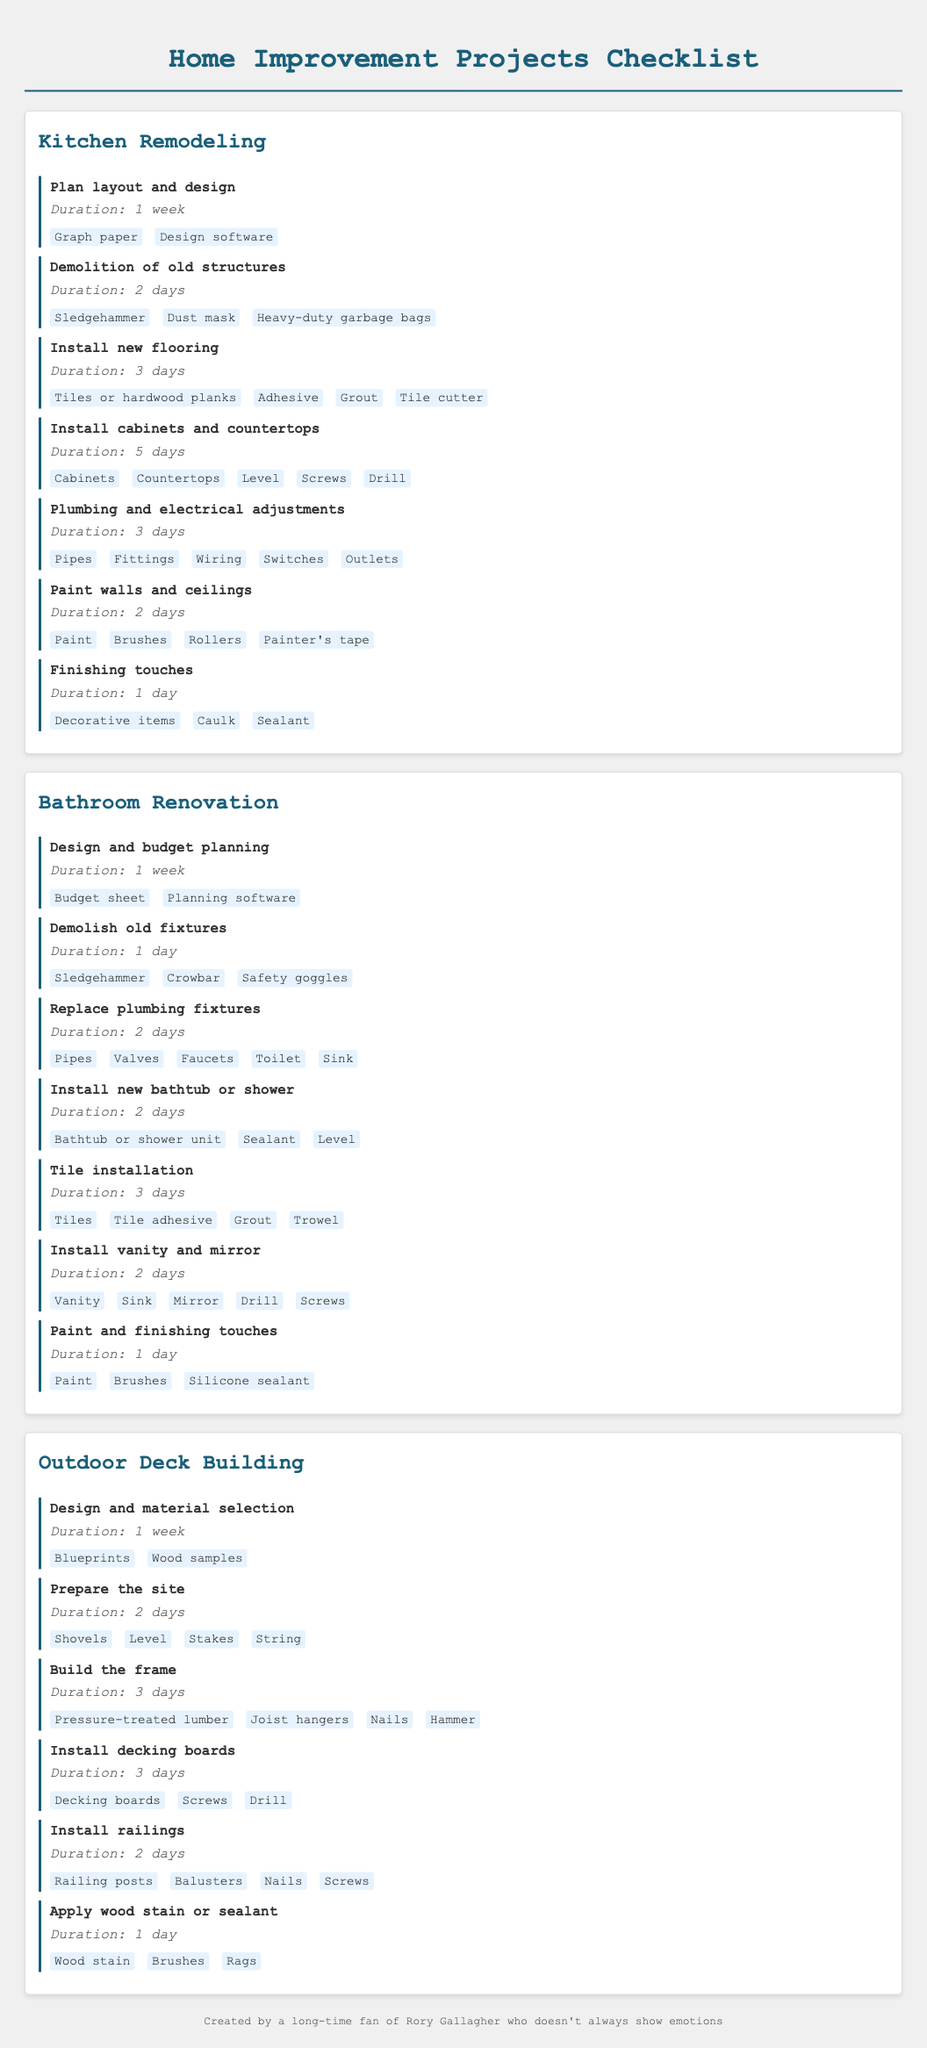What is the duration for installing cabinets and countertops? The duration for installing cabinets and countertops is specified in the kitchen remodeling section of the document.
Answer: 5 days What materials are needed for demolishing old structures in the kitchen? The materials listed for demolishing old structures include items that specifically help with this task in the kitchen remodeling section.
Answer: Sledgehammer, Dust mask, Heavy-duty garbage bags How many days does the tile installation in the bathroom take? The document explicitly states the duration for tile installation under the bathroom renovation section.
Answer: 3 days What task requires the use of wood stain in outdoor deck building? The specific task that involves wood stain is outlined in the outdoor deck building section of the document.
Answer: Apply wood stain or sealant Name one material needed for the design and material selection task in outdoor deck building. The task of design and material selection lists materials that assist in this process.
Answer: Blueprints What is the total duration required for plumbing and electrical adjustments in the kitchen? The total duration is specified in the kitchen remodeling section and is needed for the plumbing and electrical adjustments task.
Answer: 3 days How many tasks are listed in the bathroom renovation section? The document contains a count of tasks detailed in the bathroom renovation section.
Answer: 7 What is the first task in the outdoor deck building project? The first task listed for the outdoor deck building project is found at the beginning of that section.
Answer: Design and material selection 